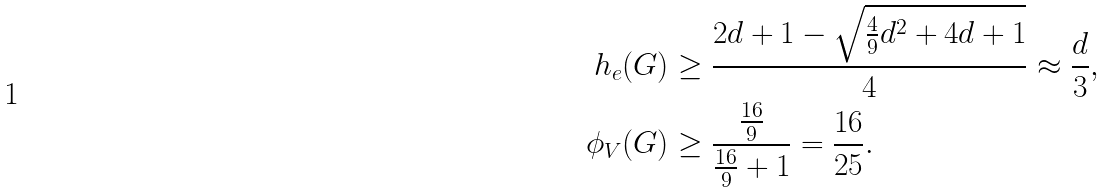<formula> <loc_0><loc_0><loc_500><loc_500>h _ { e } ( G ) & \geq \frac { 2 d + 1 - \sqrt { \frac { 4 } { 9 } d ^ { 2 } + 4 d + 1 } } { 4 } \approx \frac { d } { 3 } , \\ \phi _ { V } ( G ) & \geq \frac { \frac { 1 6 } { 9 } } { \frac { 1 6 } { 9 } + 1 } = \frac { 1 6 } { 2 5 } .</formula> 